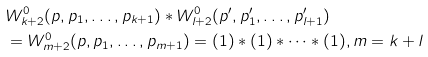<formula> <loc_0><loc_0><loc_500><loc_500>& W ^ { 0 } _ { k + 2 } ( p , p _ { 1 } , \dots , p _ { k + 1 } ) \ast W ^ { 0 } _ { l + 2 } ( p ^ { \prime } , p ^ { \prime } _ { 1 } , \dots , p ^ { \prime } _ { l + 1 } ) \\ & = W ^ { 0 } _ { m + 2 } ( p , p _ { 1 } , \dots , p _ { m + 1 } ) = ( 1 ) \ast ( 1 ) \ast \dots \ast ( 1 ) , m = k + l</formula> 